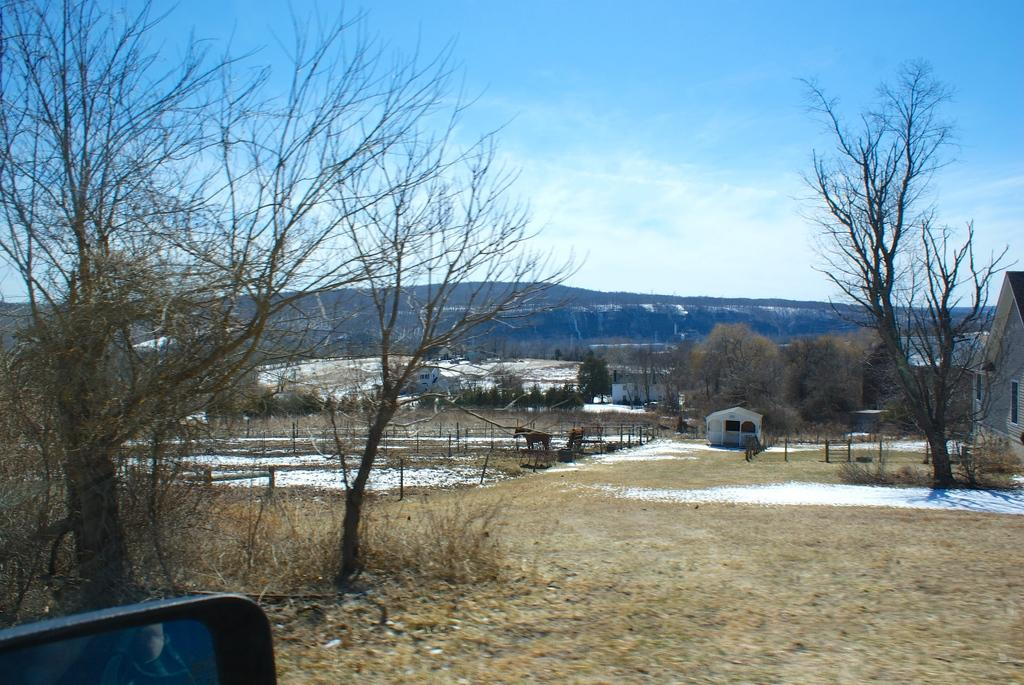What type of structures can be seen in the image? There are houses in the image. What feature of the houses is visible? There are windows visible in the image. What type of natural elements are present in the image? There are trees and mountains in the image. What type of animal can be seen in the image? There is an animal in the image. What type of barrier is present in the image? There is fencing in the image. What is the color of the sky in the image? The sky is in white and blue color. What type of wound can be seen on the animal in the image? There is no wound visible on the animal in the image. What type of discovery was made by the animal in the image? There is no indication of a discovery made by the animal in the image. What type of destruction is happening to the houses in the image? There is no destruction happening to the houses in the image. 